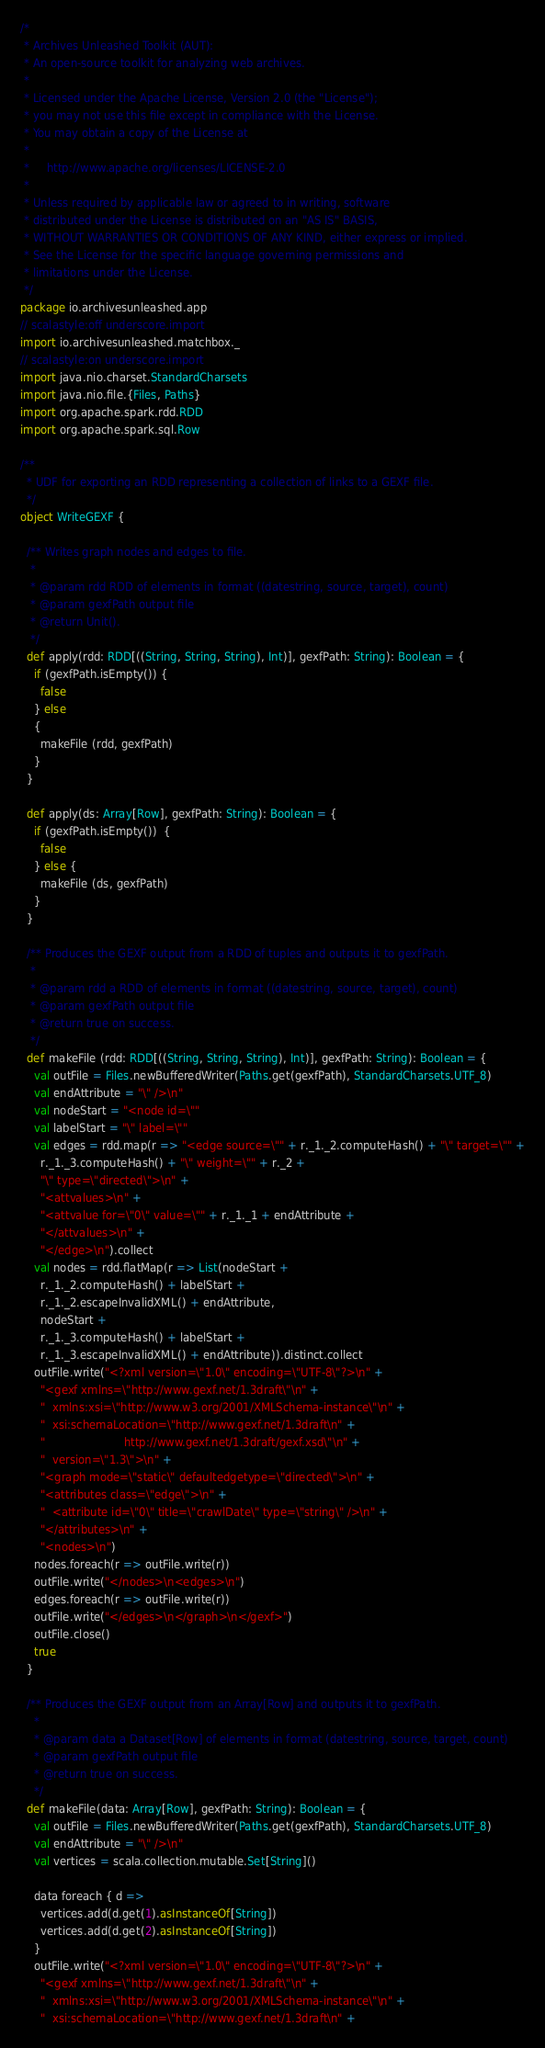Convert code to text. <code><loc_0><loc_0><loc_500><loc_500><_Scala_>/*
 * Archives Unleashed Toolkit (AUT):
 * An open-source toolkit for analyzing web archives.
 *
 * Licensed under the Apache License, Version 2.0 (the "License");
 * you may not use this file except in compliance with the License.
 * You may obtain a copy of the License at
 *
 *     http://www.apache.org/licenses/LICENSE-2.0
 *
 * Unless required by applicable law or agreed to in writing, software
 * distributed under the License is distributed on an "AS IS" BASIS,
 * WITHOUT WARRANTIES OR CONDITIONS OF ANY KIND, either express or implied.
 * See the License for the specific language governing permissions and
 * limitations under the License.
 */
package io.archivesunleashed.app
// scalastyle:off underscore.import
import io.archivesunleashed.matchbox._
// scalastyle:on underscore.import
import java.nio.charset.StandardCharsets
import java.nio.file.{Files, Paths}
import org.apache.spark.rdd.RDD
import org.apache.spark.sql.Row

/**
  * UDF for exporting an RDD representing a collection of links to a GEXF file.
  */
object WriteGEXF {

  /** Writes graph nodes and edges to file.
   *
   * @param rdd RDD of elements in format ((datestring, source, target), count)
   * @param gexfPath output file
   * @return Unit().
   */
  def apply(rdd: RDD[((String, String, String), Int)], gexfPath: String): Boolean = {
    if (gexfPath.isEmpty()) {
      false
    } else
    {
      makeFile (rdd, gexfPath)
    }
  }

  def apply(ds: Array[Row], gexfPath: String): Boolean = {
    if (gexfPath.isEmpty())  {
      false
    } else {
      makeFile (ds, gexfPath)
    }
  }

  /** Produces the GEXF output from a RDD of tuples and outputs it to gexfPath.
   *
   * @param rdd a RDD of elements in format ((datestring, source, target), count)
   * @param gexfPath output file
   * @return true on success.
   */
  def makeFile (rdd: RDD[((String, String, String), Int)], gexfPath: String): Boolean = {
    val outFile = Files.newBufferedWriter(Paths.get(gexfPath), StandardCharsets.UTF_8)
    val endAttribute = "\" />\n"
    val nodeStart = "<node id=\""
    val labelStart = "\" label=\""
    val edges = rdd.map(r => "<edge source=\"" + r._1._2.computeHash() + "\" target=\"" +
      r._1._3.computeHash() + "\" weight=\"" + r._2 +
      "\" type=\"directed\">\n" +
      "<attvalues>\n" +
      "<attvalue for=\"0\" value=\"" + r._1._1 + endAttribute +
      "</attvalues>\n" +
      "</edge>\n").collect
    val nodes = rdd.flatMap(r => List(nodeStart +
      r._1._2.computeHash() + labelStart +
      r._1._2.escapeInvalidXML() + endAttribute,
      nodeStart +
      r._1._3.computeHash() + labelStart +
      r._1._3.escapeInvalidXML() + endAttribute)).distinct.collect
    outFile.write("<?xml version=\"1.0\" encoding=\"UTF-8\"?>\n" +
      "<gexf xmlns=\"http://www.gexf.net/1.3draft\"\n" +
      "  xmlns:xsi=\"http://www.w3.org/2001/XMLSchema-instance\"\n" +
      "  xsi:schemaLocation=\"http://www.gexf.net/1.3draft\n" +
      "                       http://www.gexf.net/1.3draft/gexf.xsd\"\n" +
      "  version=\"1.3\">\n" +
      "<graph mode=\"static\" defaultedgetype=\"directed\">\n" +
      "<attributes class=\"edge\">\n" +
      "  <attribute id=\"0\" title=\"crawlDate\" type=\"string\" />\n" +
      "</attributes>\n" +
      "<nodes>\n")
    nodes.foreach(r => outFile.write(r))
    outFile.write("</nodes>\n<edges>\n")
    edges.foreach(r => outFile.write(r))
    outFile.write("</edges>\n</graph>\n</gexf>")
    outFile.close()
    true
  }

  /** Produces the GEXF output from an Array[Row] and outputs it to gexfPath.
    *
    * @param data a Dataset[Row] of elements in format (datestring, source, target, count)
    * @param gexfPath output file
    * @return true on success.
    */
  def makeFile(data: Array[Row], gexfPath: String): Boolean = {
    val outFile = Files.newBufferedWriter(Paths.get(gexfPath), StandardCharsets.UTF_8)
    val endAttribute = "\" />\n"
    val vertices = scala.collection.mutable.Set[String]()

    data foreach { d =>
      vertices.add(d.get(1).asInstanceOf[String])
      vertices.add(d.get(2).asInstanceOf[String])
    }
    outFile.write("<?xml version=\"1.0\" encoding=\"UTF-8\"?>\n" +
      "<gexf xmlns=\"http://www.gexf.net/1.3draft\"\n" +
      "  xmlns:xsi=\"http://www.w3.org/2001/XMLSchema-instance\"\n" +
      "  xsi:schemaLocation=\"http://www.gexf.net/1.3draft\n" +</code> 